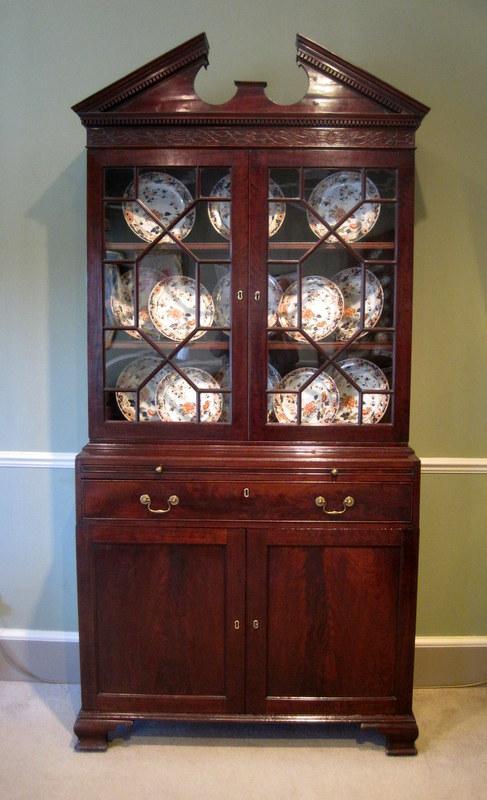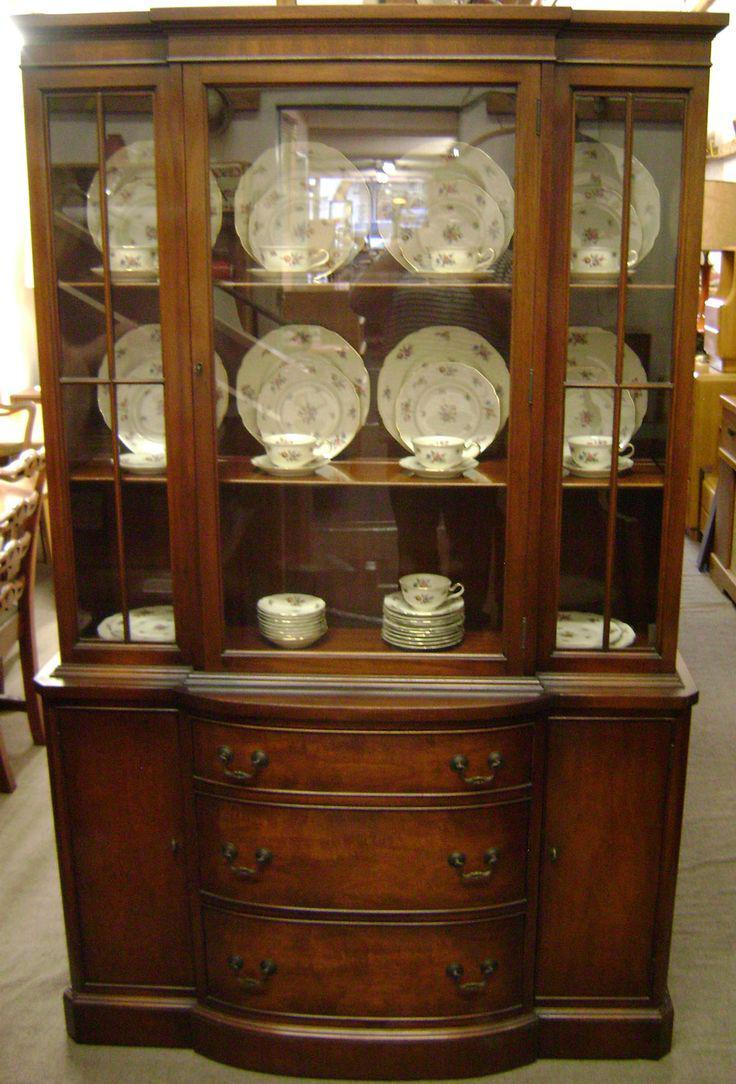The first image is the image on the left, the second image is the image on the right. For the images shown, is this caption "A wooden hutch with three rows of dishes in its upper glass-paned section has three drawers between two doors in its lower section." true? Answer yes or no. Yes. The first image is the image on the left, the second image is the image on the right. Given the left and right images, does the statement "The cabinet in the image on the right is set in the corner of a room." hold true? Answer yes or no. No. 